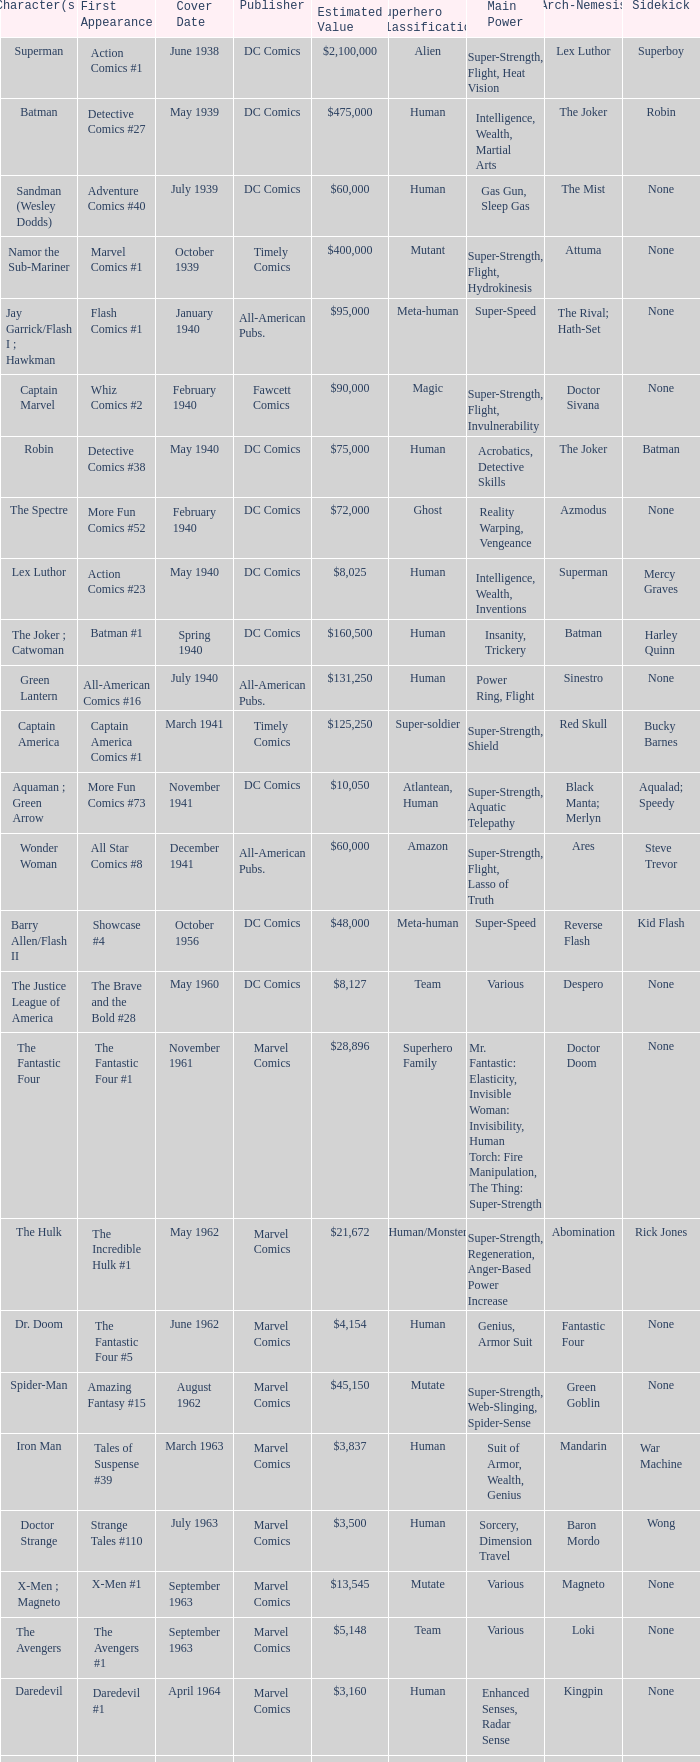Who releases wolverine? Marvel Comics. Help me parse the entirety of this table. {'header': ['Character(s)', 'First Appearance', 'Cover Date', 'Publisher', 'Estimated Value', 'Superhero Classification', 'Main Power', 'Arch-Nemesis', 'Sidekick'], 'rows': [['Superman', 'Action Comics #1', 'June 1938', 'DC Comics', '$2,100,000', 'Alien', 'Super-Strength, Flight, Heat Vision', 'Lex Luthor', 'Superboy'], ['Batman', 'Detective Comics #27', 'May 1939', 'DC Comics', '$475,000', 'Human', 'Intelligence, Wealth, Martial Arts', 'The Joker', 'Robin'], ['Sandman (Wesley Dodds)', 'Adventure Comics #40', 'July 1939', 'DC Comics', '$60,000', 'Human', 'Gas Gun, Sleep Gas', 'The Mist', 'None'], ['Namor the Sub-Mariner', 'Marvel Comics #1', 'October 1939', 'Timely Comics', '$400,000', 'Mutant', 'Super-Strength, Flight, Hydrokinesis', 'Attuma', 'None'], ['Jay Garrick/Flash I ; Hawkman', 'Flash Comics #1', 'January 1940', 'All-American Pubs.', '$95,000', 'Meta-human', 'Super-Speed', 'The Rival; Hath-Set', 'None'], ['Captain Marvel', 'Whiz Comics #2', 'February 1940', 'Fawcett Comics', '$90,000', 'Magic', 'Super-Strength, Flight, Invulnerability', 'Doctor Sivana', 'None'], ['Robin', 'Detective Comics #38', 'May 1940', 'DC Comics', '$75,000', 'Human', 'Acrobatics, Detective Skills', 'The Joker', 'Batman'], ['The Spectre', 'More Fun Comics #52', 'February 1940', 'DC Comics', '$72,000', 'Ghost', 'Reality Warping, Vengeance', 'Azmodus', 'None'], ['Lex Luthor', 'Action Comics #23', 'May 1940', 'DC Comics', '$8,025', 'Human', 'Intelligence, Wealth, Inventions', 'Superman', 'Mercy Graves'], ['The Joker ; Catwoman', 'Batman #1', 'Spring 1940', 'DC Comics', '$160,500', 'Human', 'Insanity, Trickery', 'Batman', 'Harley Quinn'], ['Green Lantern', 'All-American Comics #16', 'July 1940', 'All-American Pubs.', '$131,250', 'Human', 'Power Ring, Flight', 'Sinestro', 'None'], ['Captain America', 'Captain America Comics #1', 'March 1941', 'Timely Comics', '$125,250', 'Super-soldier', 'Super-Strength, Shield', 'Red Skull', 'Bucky Barnes'], ['Aquaman ; Green Arrow', 'More Fun Comics #73', 'November 1941', 'DC Comics', '$10,050', 'Atlantean, Human', 'Super-Strength, Aquatic Telepathy', 'Black Manta; Merlyn', 'Aqualad; Speedy'], ['Wonder Woman', 'All Star Comics #8', 'December 1941', 'All-American Pubs.', '$60,000', 'Amazon', 'Super-Strength, Flight, Lasso of Truth', 'Ares', 'Steve Trevor'], ['Barry Allen/Flash II', 'Showcase #4', 'October 1956', 'DC Comics', '$48,000', 'Meta-human', 'Super-Speed', 'Reverse Flash', 'Kid Flash'], ['The Justice League of America', 'The Brave and the Bold #28', 'May 1960', 'DC Comics', '$8,127', 'Team', 'Various', 'Despero', 'None'], ['The Fantastic Four', 'The Fantastic Four #1', 'November 1961', 'Marvel Comics', '$28,896', 'Superhero Family', 'Mr. Fantastic: Elasticity, Invisible Woman: Invisibility, Human Torch: Fire Manipulation, The Thing: Super-Strength', 'Doctor Doom', 'None'], ['The Hulk', 'The Incredible Hulk #1', 'May 1962', 'Marvel Comics', '$21,672', 'Human/Monster', 'Super-Strength, Regeneration, Anger-Based Power Increase', 'Abomination', 'Rick Jones'], ['Dr. Doom', 'The Fantastic Four #5', 'June 1962', 'Marvel Comics', '$4,154', 'Human', 'Genius, Armor Suit', 'Fantastic Four', 'None'], ['Spider-Man', 'Amazing Fantasy #15', 'August 1962', 'Marvel Comics', '$45,150', 'Mutate', 'Super-Strength, Web-Slinging, Spider-Sense', 'Green Goblin', 'None'], ['Iron Man', 'Tales of Suspense #39', 'March 1963', 'Marvel Comics', '$3,837', 'Human', 'Suit of Armor, Wealth, Genius', 'Mandarin', 'War Machine'], ['Doctor Strange', 'Strange Tales #110', 'July 1963', 'Marvel Comics', '$3,500', 'Human', 'Sorcery, Dimension Travel', 'Baron Mordo', 'Wong'], ['X-Men ; Magneto', 'X-Men #1', 'September 1963', 'Marvel Comics', '$13,545', 'Mutate', 'Various', 'Magneto', 'None'], ['The Avengers', 'The Avengers #1', 'September 1963', 'Marvel Comics', '$5,148', 'Team', 'Various', 'Loki', 'None'], ['Daredevil', 'Daredevil #1', 'April 1964', 'Marvel Comics', '$3,160', 'Human', 'Enhanced Senses, Radar Sense', 'Kingpin', 'None'], ['Teen Titans', 'The Brave and the Bold #54', 'July 1964', 'DC Comics', '$415', 'Team', 'Various', 'Deathstroke', 'None'], ['The Punisher', 'The Amazing Spider-Man #129', 'February 1974', 'Marvel Comics', '$918', 'Human', 'Military Training, Arsenal of Weapons', 'Jigsaw', 'Microchip'], ['Wolverine', 'The Incredible Hulk #180', 'October 1974', 'Marvel Comics', '$350', 'Mutant', 'Super-Strength, Regeneration, Claws', 'Sabretooth', 'None'], ['Teenage Mutant Ninja Turtles', 'Teenage Mutant Ninja Turtles #1', 'May 1984', 'Mirage Studios', '$2,400', 'Mutate', 'Martial Arts, Weapon Proficiency', 'Shredder', "April O'Neil"]]} 